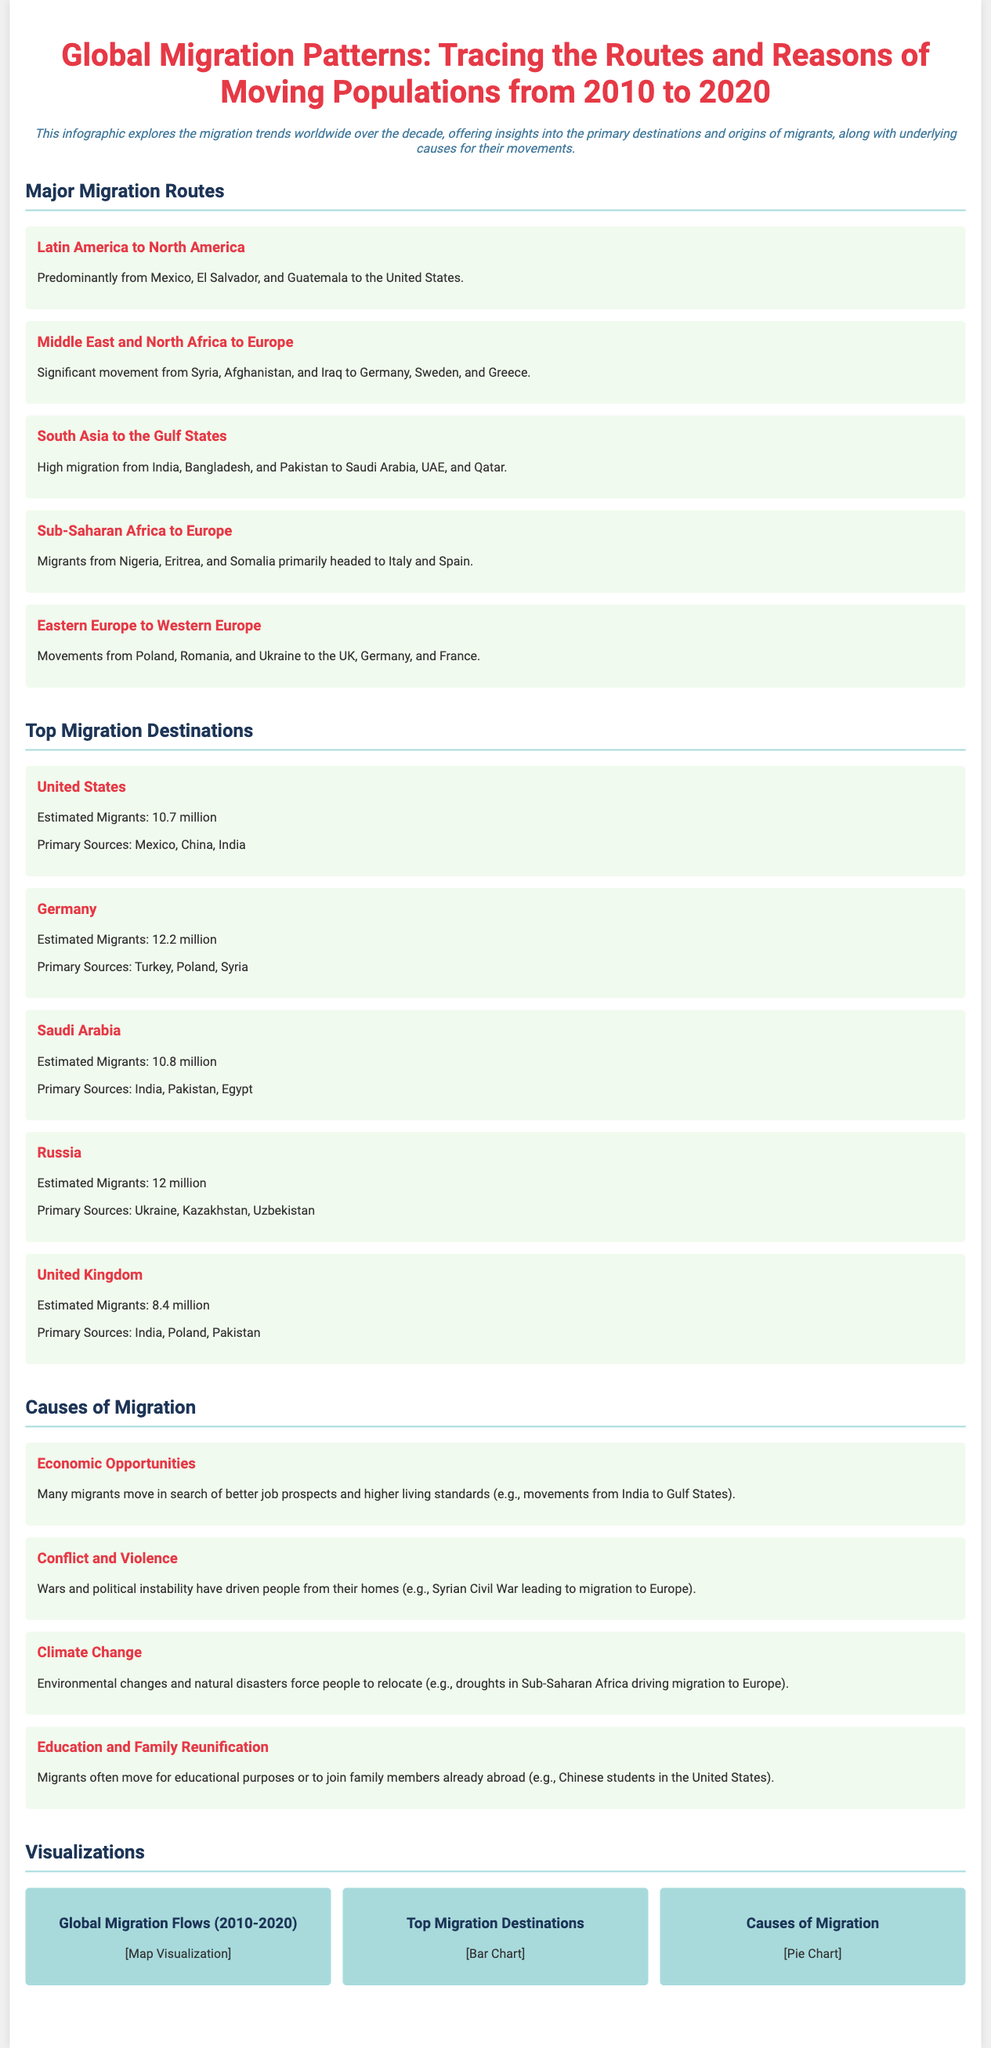What are the primary sources of migrants to the United States? The primary sources listed are Mexico, China, and India.
Answer: Mexico, China, India How many estimated migrants are in Germany? The document states there are approximately 12.2 million migrants in Germany.
Answer: 12.2 million What migration route is described from Latin America? The route is predominantly from Mexico, El Salvador, and Guatemala to the United States.
Answer: Mexico, El Salvador, Guatemala What is one of the causes of migration mentioned in the infographic? The document explicitly mentions economic opportunities as a cause of migration.
Answer: Economic Opportunities Which country has the highest number of estimated migrants? The highest estimated migrants are in Germany, with 12.2 million.
Answer: Germany What visual representation is provided for the causes of migration? The document indicates a pie chart visualizes the causes of migration.
Answer: Pie chart Which country is the primary destination for migrants from Nigeria? The document mentions Italy as a primary destination for migrants from Nigeria.
Answer: Italy What major conflict drove migration from Syria? The Syrian Civil War is identified as the conflict leading to migration to Europe.
Answer: Syrian Civil War 